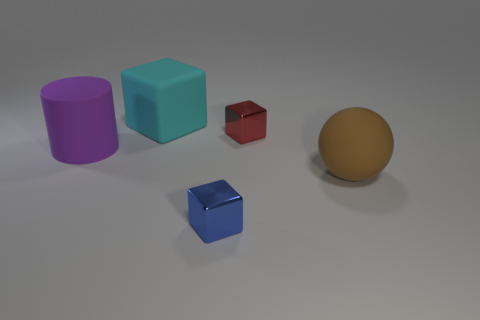How many other things are there of the same material as the blue object?
Give a very brief answer. 1. How many rubber things are on the left side of the small cube that is in front of the matte sphere?
Your answer should be very brief. 2. Are there any other things that are the same shape as the big cyan matte object?
Offer a very short reply. Yes. Are there fewer brown matte objects than small blue matte spheres?
Your answer should be compact. No. There is a thing that is right of the metal cube that is on the right side of the blue block; what shape is it?
Make the answer very short. Sphere. There is a metallic object behind the rubber object on the right side of the small cube that is in front of the rubber ball; what shape is it?
Provide a succinct answer. Cube. How many objects are small red blocks right of the rubber cube or tiny things that are on the left side of the brown object?
Your response must be concise. 2. There is a matte sphere; does it have the same size as the purple cylinder that is left of the big block?
Offer a terse response. Yes. Does the purple object in front of the rubber cube have the same material as the tiny cube in front of the brown rubber thing?
Offer a terse response. No. Are there the same number of large cubes to the left of the cyan thing and tiny blue cubes behind the sphere?
Ensure brevity in your answer.  Yes. 